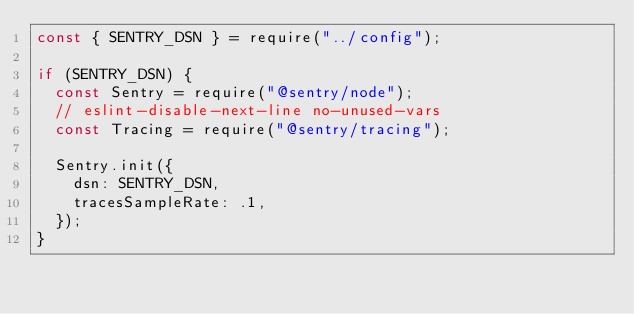<code> <loc_0><loc_0><loc_500><loc_500><_JavaScript_>const { SENTRY_DSN } = require("../config");

if (SENTRY_DSN) {
	const Sentry = require("@sentry/node");
	// eslint-disable-next-line no-unused-vars
	const Tracing = require("@sentry/tracing");

	Sentry.init({
		dsn: SENTRY_DSN,
		tracesSampleRate: .1,
	});
}
</code> 